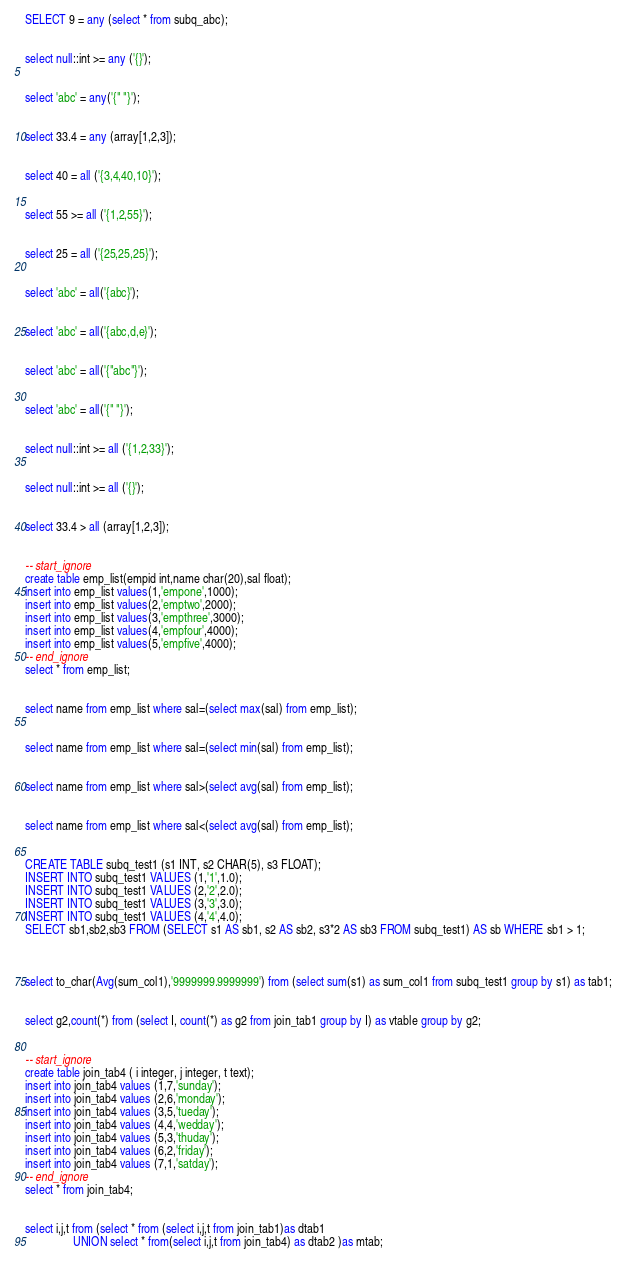<code> <loc_0><loc_0><loc_500><loc_500><_SQL_>
SELECT 9 = any (select * from subq_abc);
                         

select null::int >= any ('{}');
                         

select 'abc' = any('{" "}');
                         

select 33.4 = any (array[1,2,3]);
                         

select 40 = all ('{3,4,40,10}');
                         

select 55 >= all ('{1,2,55}');
			 

select 25 = all ('{25,25,25}');
		          

select 'abc' = all('{abc}');
                         

select 'abc' = all('{abc,d,e}');
                         

select 'abc' = all('{"abc"}');
                         

select 'abc' = all('{" "}');
                         

select null::int >= all ('{1,2,33}');
                         

select null::int >= all ('{}');
                         

select 33.4 > all (array[1,2,3]);                       
                         

-- start_ignore
create table emp_list(empid int,name char(20),sal float); 
insert into emp_list values(1,'empone',1000); 
insert into emp_list values(2,'emptwo',2000); 
insert into emp_list values(3,'empthree',3000); 
insert into emp_list values(4,'empfour',4000); 
insert into emp_list values(5,'empfive',4000); 
-- end_ignore
select * from emp_list;
                       

select name from emp_list where sal=(select max(sal) from emp_list);
                        

select name from emp_list where sal=(select min(sal) from emp_list);
                       

select name from emp_list where sal>(select avg(sal) from emp_list);
                       

select name from emp_list where sal<(select avg(sal) from emp_list);
                      

CREATE TABLE subq_test1 (s1 INT, s2 CHAR(5), s3 FLOAT);
INSERT INTO subq_test1 VALUES (1,'1',1.0); 
INSERT INTO subq_test1 VALUES (2,'2',2.0);
INSERT INTO subq_test1 VALUES (3,'3',3.0);
INSERT INTO subq_test1 VALUES (4,'4',4.0);
SELECT sb1,sb2,sb3 FROM (SELECT s1 AS sb1, s2 AS sb2, s3*2 AS sb3 FROM subq_test1) AS sb WHERE sb1 > 1;

                      

select to_char(Avg(sum_col1),'9999999.9999999') from (select sum(s1) as sum_col1 from subq_test1 group by s1) as tab1;
                      

select g2,count(*) from (select I, count(*) as g2 from join_tab1 group by I) as vtable group by g2;
                      

-- start_ignore
create table join_tab4 ( i integer, j integer, t text);
insert into join_tab4 values (1,7,'sunday'); 
insert into join_tab4 values (2,6,'monday');
insert into join_tab4 values (3,5,'tueday');
insert into join_tab4 values (4,4,'wedday');
insert into join_tab4 values (5,3,'thuday');
insert into join_tab4 values (6,2,'friday');
insert into join_tab4 values (7,1,'satday');
-- end_ignore
select * from join_tab4;
                      

select i,j,t from (select * from (select i,j,t from join_tab1)as dtab1 
				UNION select * from(select i,j,t from join_tab4) as dtab2 )as mtab; 	
                      
</code> 